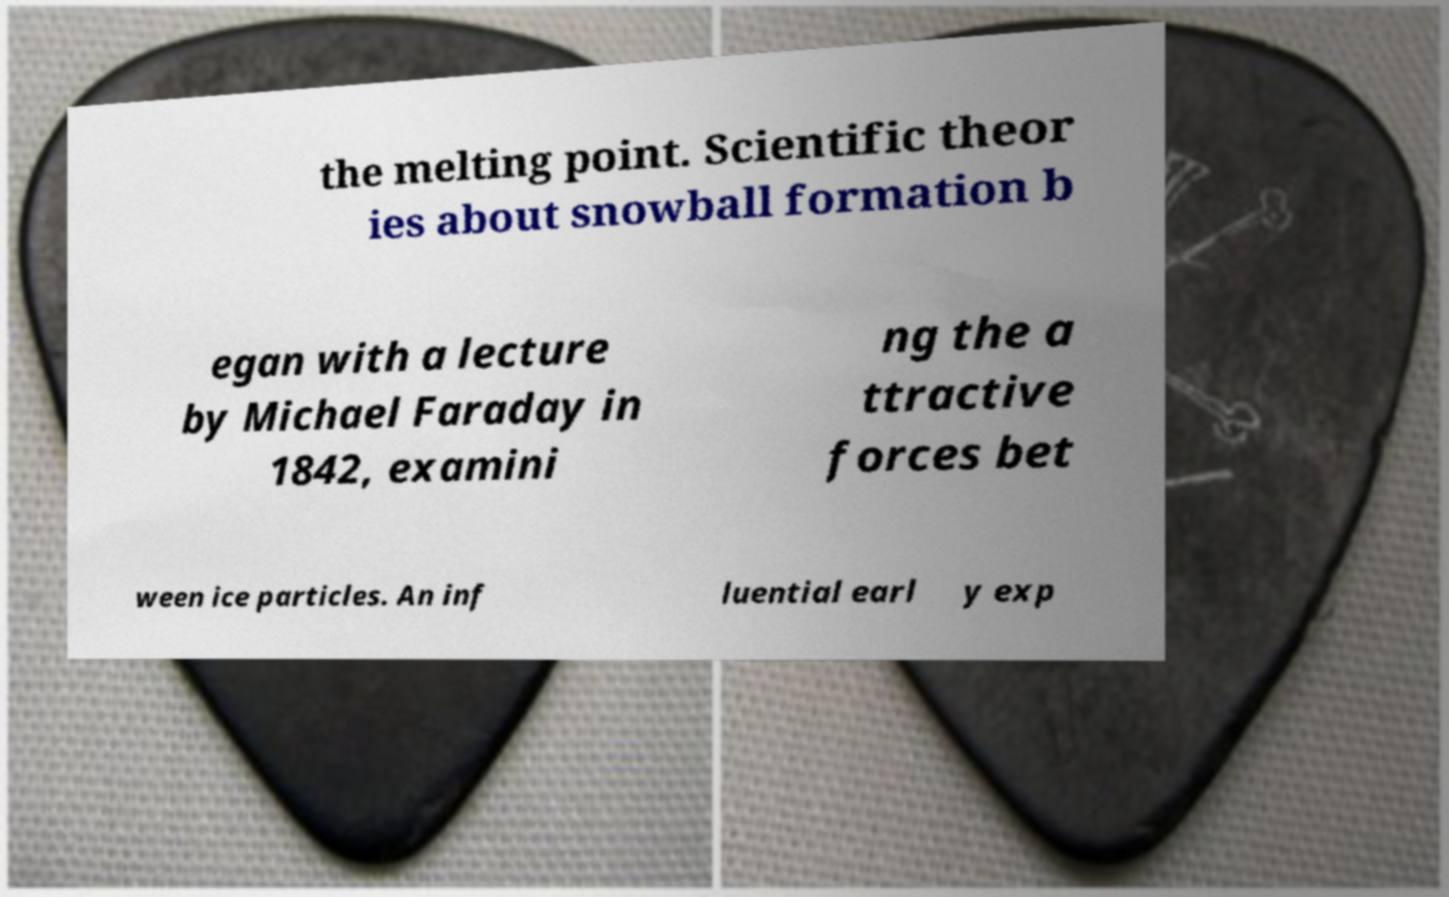For documentation purposes, I need the text within this image transcribed. Could you provide that? the melting point. Scientific theor ies about snowball formation b egan with a lecture by Michael Faraday in 1842, examini ng the a ttractive forces bet ween ice particles. An inf luential earl y exp 